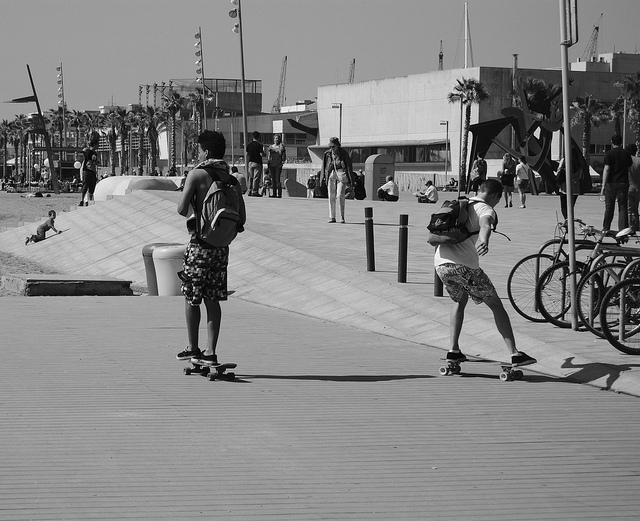How many bicycles are there?
Give a very brief answer. 4. How many bikes are there?
Give a very brief answer. 4. How many people are in the photo?
Give a very brief answer. 3. How many bicycles are in the photo?
Give a very brief answer. 3. 